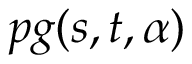Convert formula to latex. <formula><loc_0><loc_0><loc_500><loc_500>p g ( s , t , \alpha )</formula> 